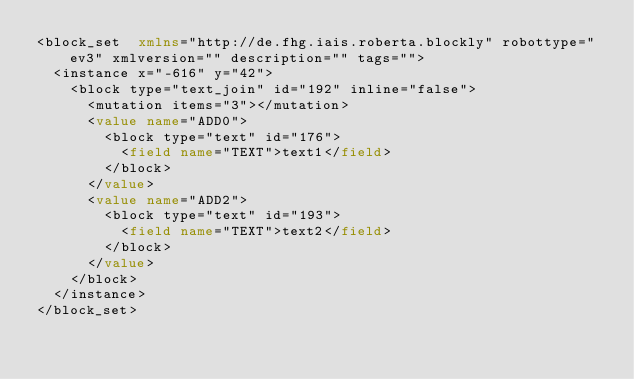Convert code to text. <code><loc_0><loc_0><loc_500><loc_500><_XML_><block_set  xmlns="http://de.fhg.iais.roberta.blockly" robottype="ev3" xmlversion="" description="" tags="">
  <instance x="-616" y="42">
    <block type="text_join" id="192" inline="false">
      <mutation items="3"></mutation>
      <value name="ADD0">
        <block type="text" id="176">
          <field name="TEXT">text1</field>
        </block>
      </value>
      <value name="ADD2">
        <block type="text" id="193">
          <field name="TEXT">text2</field>
        </block>
      </value>
    </block>
  </instance>
</block_set></code> 